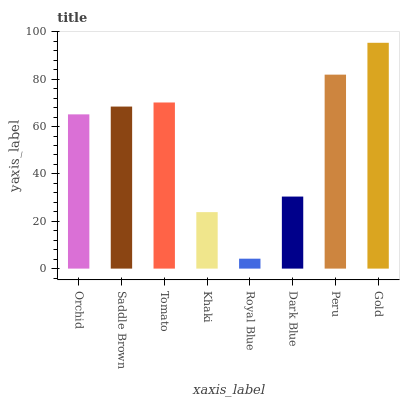Is Royal Blue the minimum?
Answer yes or no. Yes. Is Gold the maximum?
Answer yes or no. Yes. Is Saddle Brown the minimum?
Answer yes or no. No. Is Saddle Brown the maximum?
Answer yes or no. No. Is Saddle Brown greater than Orchid?
Answer yes or no. Yes. Is Orchid less than Saddle Brown?
Answer yes or no. Yes. Is Orchid greater than Saddle Brown?
Answer yes or no. No. Is Saddle Brown less than Orchid?
Answer yes or no. No. Is Saddle Brown the high median?
Answer yes or no. Yes. Is Orchid the low median?
Answer yes or no. Yes. Is Royal Blue the high median?
Answer yes or no. No. Is Dark Blue the low median?
Answer yes or no. No. 